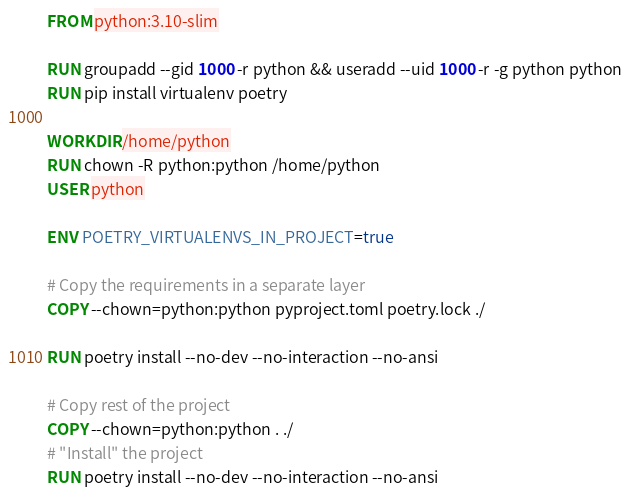<code> <loc_0><loc_0><loc_500><loc_500><_Dockerfile_>FROM python:3.10-slim

RUN groupadd --gid 1000 -r python && useradd --uid 1000 -r -g python python
RUN pip install virtualenv poetry

WORKDIR /home/python
RUN chown -R python:python /home/python
USER python

ENV POETRY_VIRTUALENVS_IN_PROJECT=true

# Copy the requirements in a separate layer
COPY --chown=python:python pyproject.toml poetry.lock ./

RUN poetry install --no-dev --no-interaction --no-ansi

# Copy rest of the project
COPY --chown=python:python . ./
# "Install" the project
RUN poetry install --no-dev --no-interaction --no-ansi
</code> 